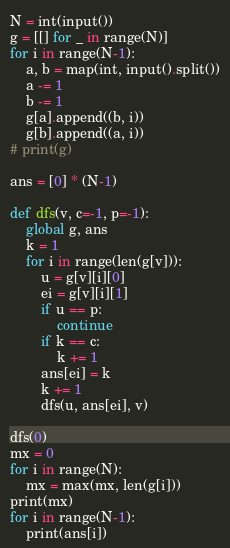<code> <loc_0><loc_0><loc_500><loc_500><_Python_>N = int(input())
g = [[] for _ in range(N)]
for i in range(N-1):
    a, b = map(int, input().split())
    a -= 1
    b -= 1
    g[a].append((b, i))
    g[b].append((a, i))
# print(g)

ans = [0] * (N-1)

def dfs(v, c=-1, p=-1):
    global g, ans
    k = 1
    for i in range(len(g[v])):
        u = g[v][i][0]
        ei = g[v][i][1]
        if u == p:
            continue
        if k == c:
            k += 1
        ans[ei] = k
        k += 1
        dfs(u, ans[ei], v)

dfs(0)
mx = 0
for i in range(N):
    mx = max(mx, len(g[i]))
print(mx)
for i in range(N-1):
    print(ans[i])
</code> 